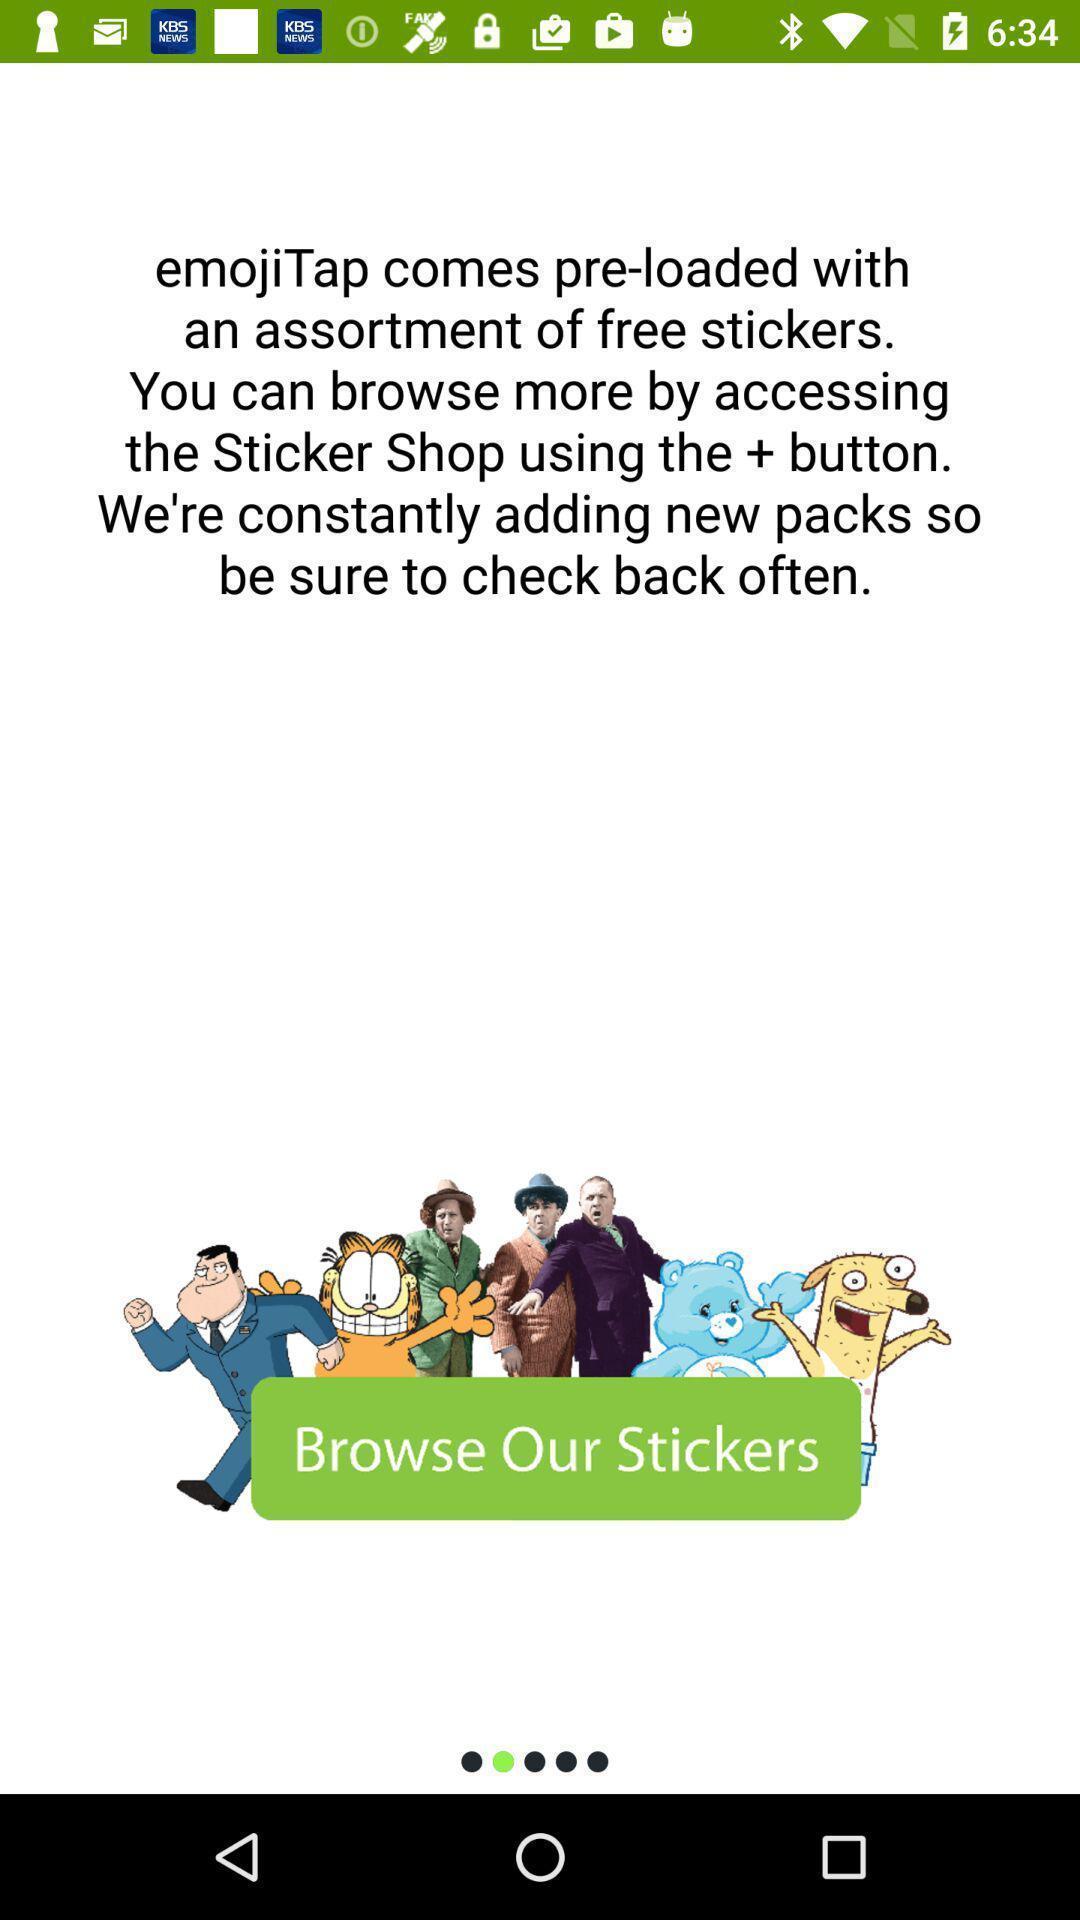Provide a description of this screenshot. Starting page of a emojis app. 